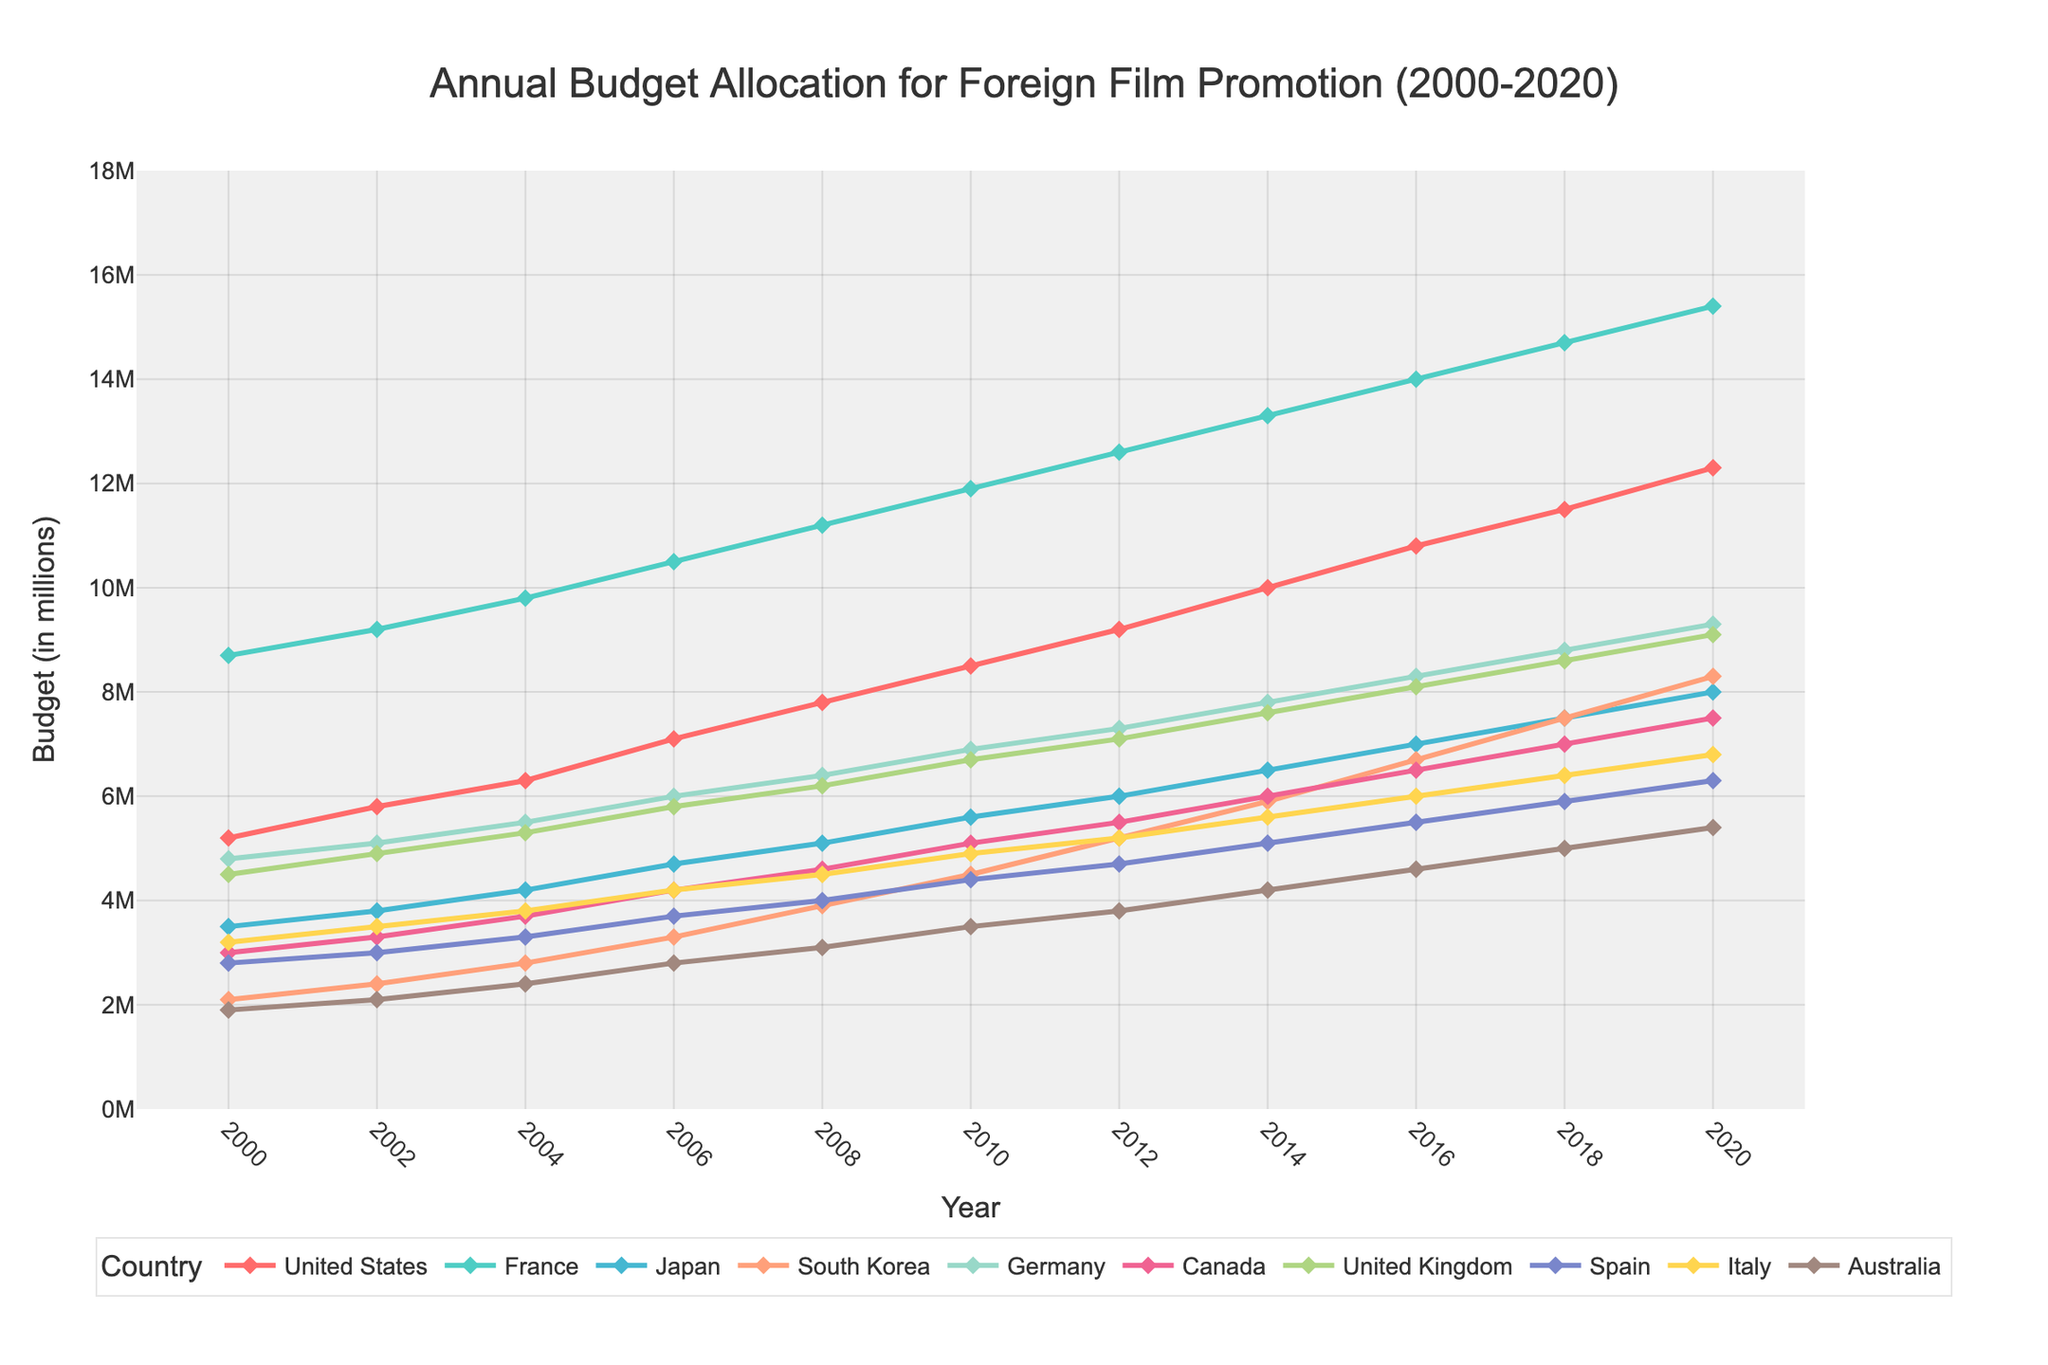Which country had the highest budget for foreign film promotion in 2008? By looking at the height of the lines in the year 2008, we can note that France had the highest budget.
Answer: France What is the difference in the budget allocated by the United States and South Korea in 2020? The budget for the United States in 2020 is 12.3 million, and for South Korea, it is 8.3 million. Subtracting 8.3 from 12.3 gives us 4.0 million.
Answer: 4.0 million In which year did Canada reach a 5 million budget allocation for foreign film promotion? The visual for Canada (cyan line) shows that it reaches the 5 million mark in the year 2010.
Answer: 2010 Which country's budget showed the most significant increase between 2006 and 2008? By comparing all the line segments between 2006 and 2008, France had an increase from 10.5 million to 11.2 million, which is the highest rise among all countries.
Answer: France How many years did it take Italy to increase its budget from 3.2 to 6.8 million? Italy's budget was 3.2 million in 2000 and reached 6.8 million in 2020, taking 20 years.
Answer: 20 years Which countries had a budget allocation of over 7 million in 2016? By examining the lines in 2016, the countries that exceeded 7 million are the United States, France, Japan, Germany, and the United Kingdom.
Answer: The United States, France, Japan, Germany, United Kingdom How did the budget allocation for foreign film promotion in Spain change from 2010 to 2014? Spain's budget increased from 4.4 million in 2010 to 5.1 million in 2014.
Answer: Increased by 0.7 million Which two countries had nearly equal budget allocations in 2000? By comparing line heights in 2000, Japan and Italy had nearly equal budgets, with 3.5 and 3.2 million respectively.
Answer: Japan and Italy What is the average budget allocation for Australia between 2010 and 2020? The budgets for Australia from 2010 to 2020 are 3.5, 3.8, 4.2, 4.6, 5.0, and 5.4 respectively. Adding these values, we get 26.5 million. Dividing by the number of years (6), the average is approximately 4.42 million.
Answer: Approximately 4.42 million 